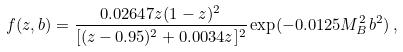Convert formula to latex. <formula><loc_0><loc_0><loc_500><loc_500>f ( z , b ) = \frac { 0 . 0 2 6 4 7 z ( 1 - z ) ^ { 2 } } { [ ( z - 0 . 9 5 ) ^ { 2 } + 0 . 0 0 3 4 z ] ^ { 2 } } \exp ( - 0 . 0 1 2 5 M _ { B } ^ { 2 } b ^ { 2 } ) \, ,</formula> 